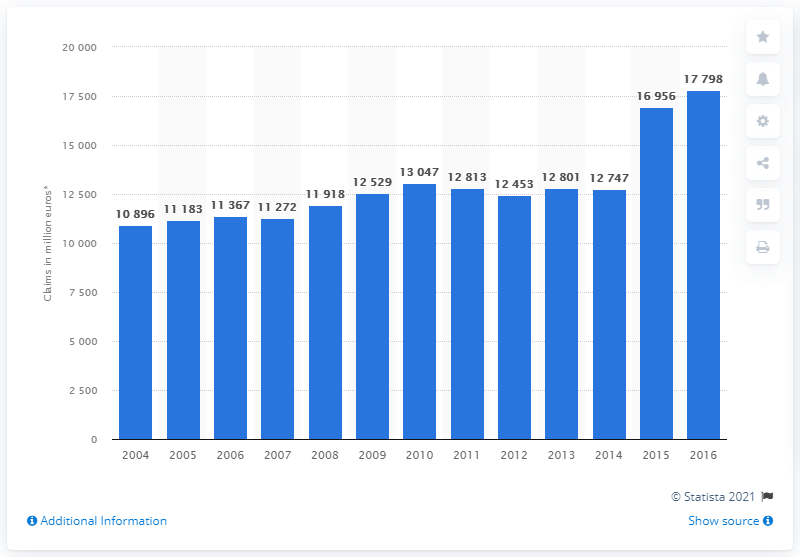Identify some key points in this picture. From 2004 to 2016, the total worth of motor insurance claims paid out by insurers in France was 17,798. 